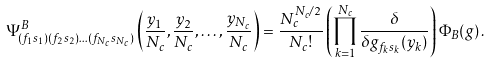Convert formula to latex. <formula><loc_0><loc_0><loc_500><loc_500>\Psi _ { ( f _ { 1 } s _ { 1 } ) ( f _ { 2 } s _ { 2 } ) \dots ( f _ { N _ { c } } s _ { N _ { c } } ) } ^ { B } \left ( \frac { y _ { 1 } } { N _ { c } } , \frac { y _ { 2 } } { N _ { c } } , \dots , \frac { y _ { N _ { c } } } { N _ { c } } \right ) = \frac { N _ { c } ^ { N _ { c } / 2 } } { N _ { c } ! } \left ( \prod _ { k = 1 } ^ { N _ { c } } \frac { \delta } { \delta g _ { f _ { k } s _ { k } } ( y _ { k } ) } \right ) \Phi _ { B } ( g ) \, .</formula> 